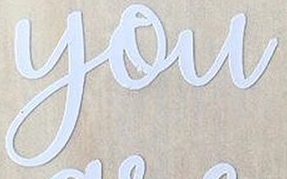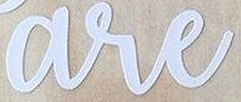Read the text from these images in sequence, separated by a semicolon. you; are 